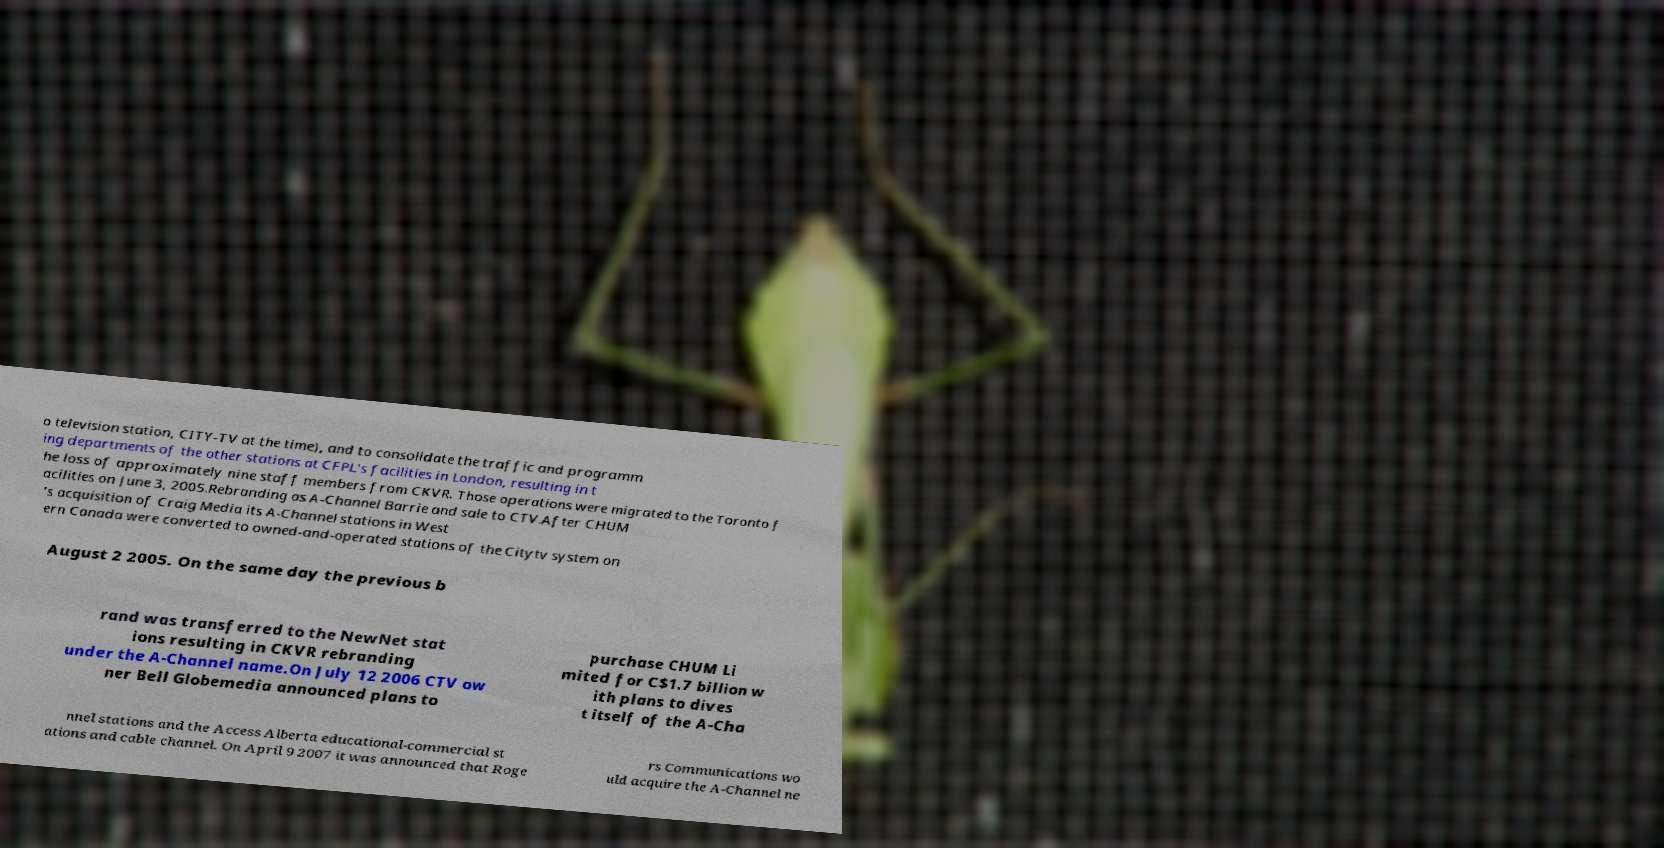For documentation purposes, I need the text within this image transcribed. Could you provide that? o television station, CITY-TV at the time), and to consolidate the traffic and programm ing departments of the other stations at CFPL's facilities in London, resulting in t he loss of approximately nine staff members from CKVR. Those operations were migrated to the Toronto f acilities on June 3, 2005.Rebranding as A-Channel Barrie and sale to CTV.After CHUM 's acquisition of Craig Media its A-Channel stations in West ern Canada were converted to owned-and-operated stations of the Citytv system on August 2 2005. On the same day the previous b rand was transferred to the NewNet stat ions resulting in CKVR rebranding under the A-Channel name.On July 12 2006 CTV ow ner Bell Globemedia announced plans to purchase CHUM Li mited for C$1.7 billion w ith plans to dives t itself of the A-Cha nnel stations and the Access Alberta educational-commercial st ations and cable channel. On April 9 2007 it was announced that Roge rs Communications wo uld acquire the A-Channel ne 